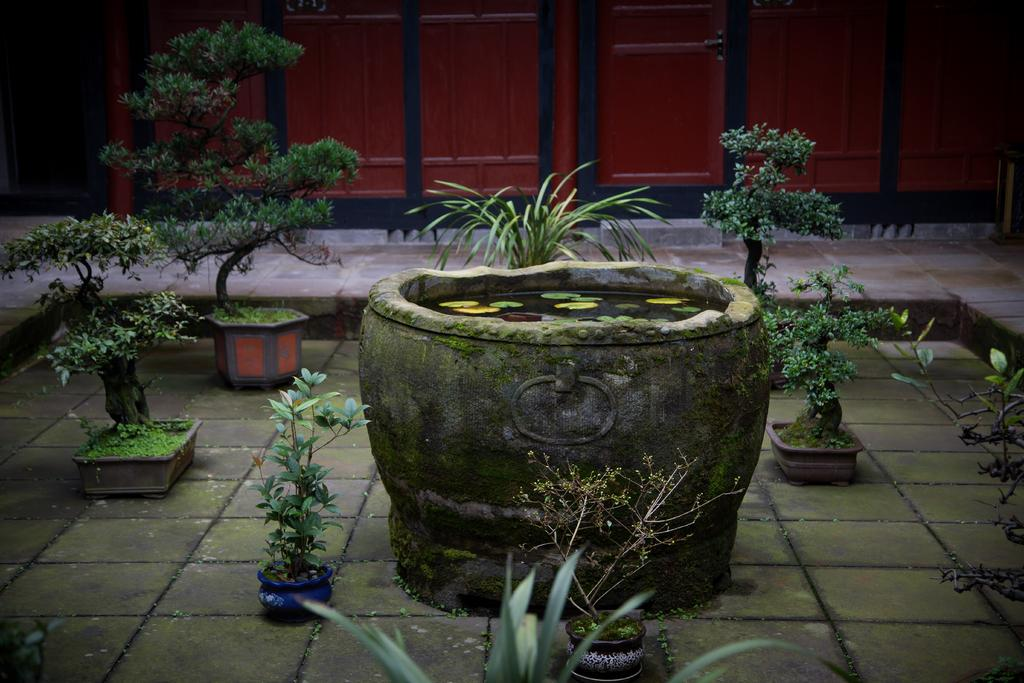What is visible in the image? There is water and plants in flower pots visible in the image. Can you describe the plants in the image? The plants are in flower pots. What type of environment might the image depict? The image might depict a garden or outdoor area with water and plants. Where is the monkey sitting in the image? There is no monkey present in the image. What type of mint is growing in the flower pots? There is no mint mentioned or visible in the image. 